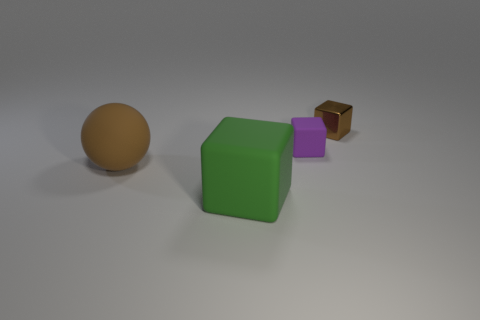Add 4 large purple rubber spheres. How many objects exist? 8 Subtract all spheres. How many objects are left? 3 Add 4 big yellow balls. How many big yellow balls exist? 4 Subtract 1 green cubes. How many objects are left? 3 Subtract all small metal things. Subtract all tiny purple matte cubes. How many objects are left? 2 Add 2 shiny cubes. How many shiny cubes are left? 3 